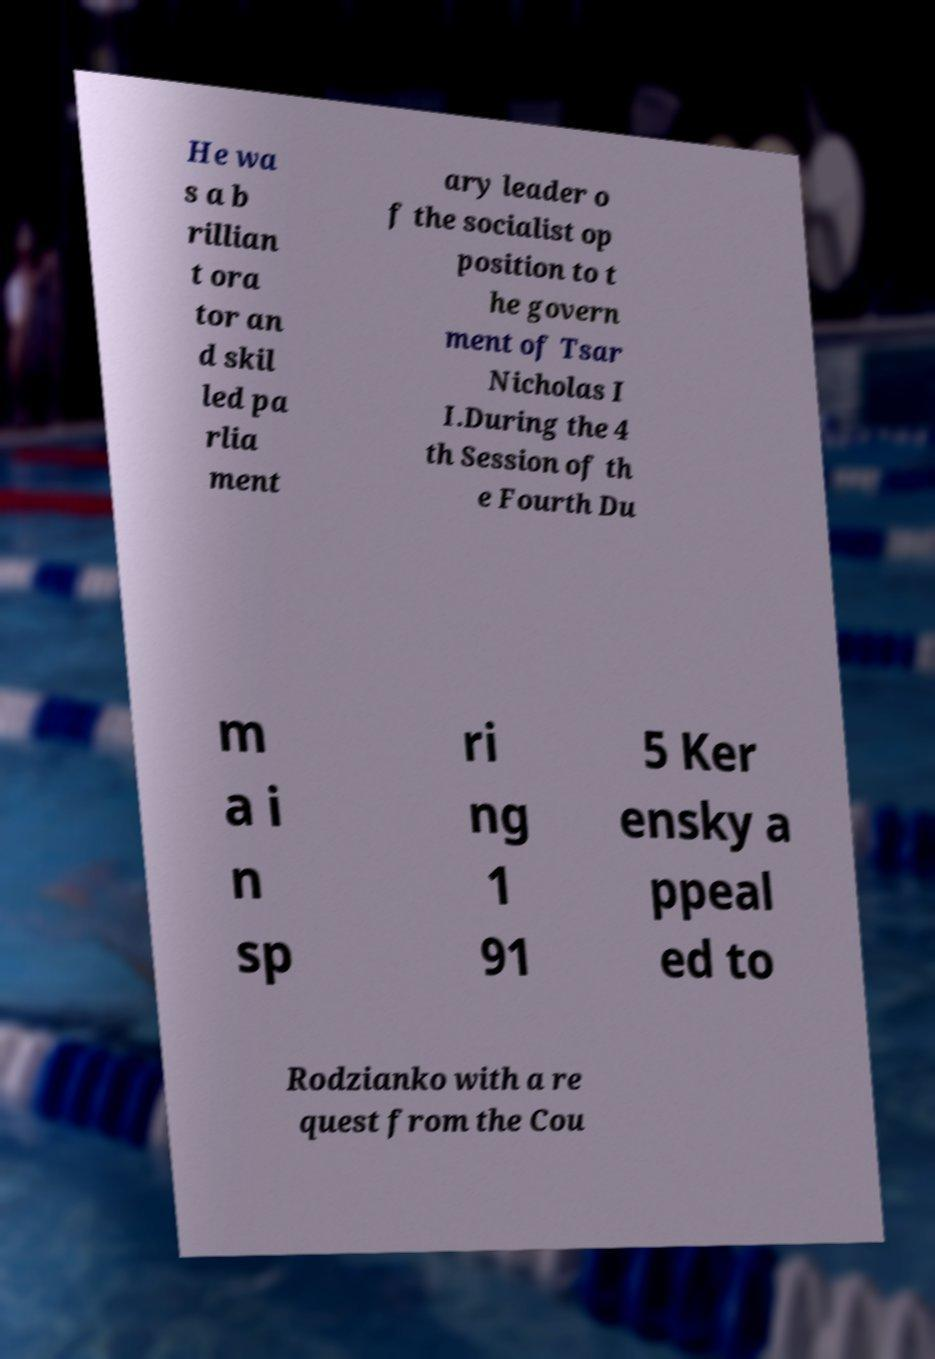Please identify and transcribe the text found in this image. He wa s a b rillian t ora tor an d skil led pa rlia ment ary leader o f the socialist op position to t he govern ment of Tsar Nicholas I I.During the 4 th Session of th e Fourth Du m a i n sp ri ng 1 91 5 Ker ensky a ppeal ed to Rodzianko with a re quest from the Cou 